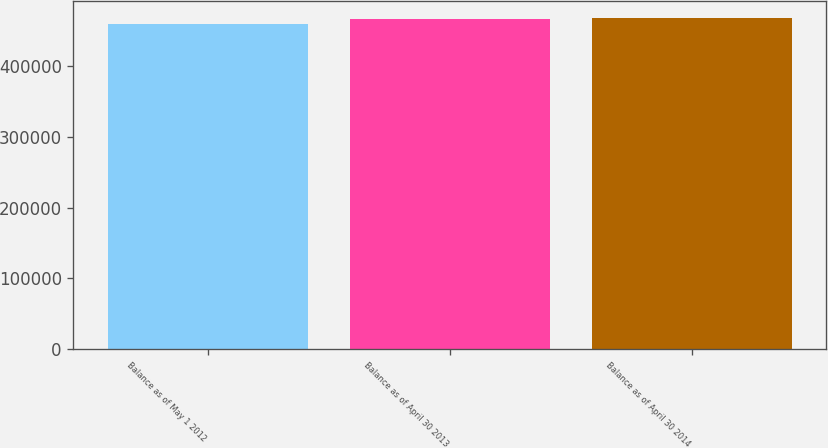Convert chart. <chart><loc_0><loc_0><loc_500><loc_500><bar_chart><fcel>Balance as of May 1 2012<fcel>Balance as of April 30 2013<fcel>Balance as of April 30 2014<nl><fcel>459863<fcel>467079<fcel>468414<nl></chart> 